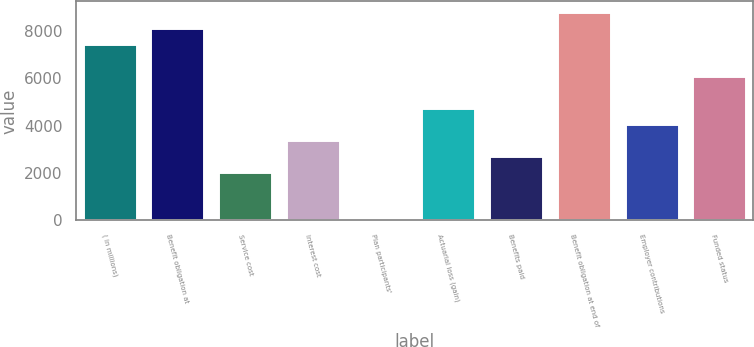Convert chart. <chart><loc_0><loc_0><loc_500><loc_500><bar_chart><fcel>( in millions)<fcel>Benefit obligation at<fcel>Service cost<fcel>Interest cost<fcel>Plan participants'<fcel>Actuarial loss (gain)<fcel>Benefits paid<fcel>Benefit obligation at end of<fcel>Employer contributions<fcel>Funded status<nl><fcel>7455.4<fcel>8132.8<fcel>2036.2<fcel>3391<fcel>4<fcel>4745.8<fcel>2713.6<fcel>8810.2<fcel>4068.4<fcel>6100.6<nl></chart> 